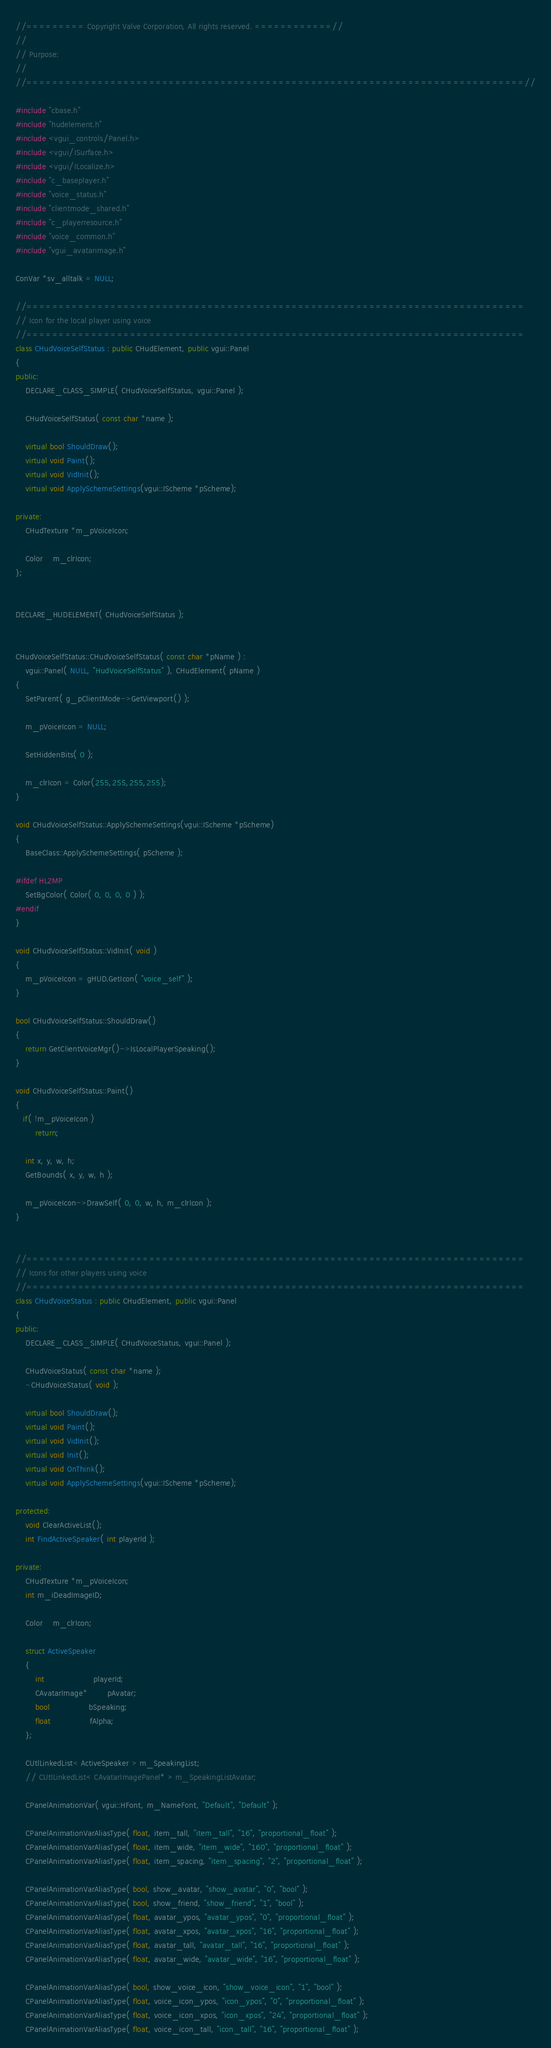Convert code to text. <code><loc_0><loc_0><loc_500><loc_500><_C++_>//========= Copyright Valve Corporation, All rights reserved. ============//
//
// Purpose: 
//
//=============================================================================//

#include "cbase.h"
#include "hudelement.h"
#include <vgui_controls/Panel.h>
#include <vgui/ISurface.h>
#include <vgui/ILocalize.h>
#include "c_baseplayer.h"
#include "voice_status.h"
#include "clientmode_shared.h"
#include "c_playerresource.h"
#include "voice_common.h"
#include "vgui_avatarimage.h"

ConVar *sv_alltalk = NULL;

//=============================================================================
// Icon for the local player using voice
//=============================================================================
class CHudVoiceSelfStatus : public CHudElement, public vgui::Panel
{
public:
	DECLARE_CLASS_SIMPLE( CHudVoiceSelfStatus, vgui::Panel );

	CHudVoiceSelfStatus( const char *name );

	virtual bool ShouldDraw();	
	virtual void Paint();
	virtual void VidInit();
	virtual void ApplySchemeSettings(vgui::IScheme *pScheme);

private:
	CHudTexture *m_pVoiceIcon;

	Color	m_clrIcon;
};


DECLARE_HUDELEMENT( CHudVoiceSelfStatus );


CHudVoiceSelfStatus::CHudVoiceSelfStatus( const char *pName ) :
	vgui::Panel( NULL, "HudVoiceSelfStatus" ), CHudElement( pName )
{
	SetParent( g_pClientMode->GetViewport() );

	m_pVoiceIcon = NULL;

	SetHiddenBits( 0 );

	m_clrIcon = Color(255,255,255,255);
}

void CHudVoiceSelfStatus::ApplySchemeSettings(vgui::IScheme *pScheme)
{
	BaseClass::ApplySchemeSettings( pScheme );

#ifdef HL2MP
	SetBgColor( Color( 0, 0, 0, 0 ) );
#endif
}

void CHudVoiceSelfStatus::VidInit( void )
{
	m_pVoiceIcon = gHUD.GetIcon( "voice_self" );
}

bool CHudVoiceSelfStatus::ShouldDraw()
{
	return GetClientVoiceMgr()->IsLocalPlayerSpeaking();
}

void CHudVoiceSelfStatus::Paint()
{
   if( !m_pVoiceIcon )
		return;
	
	int x, y, w, h;
	GetBounds( x, y, w, h );

	m_pVoiceIcon->DrawSelf( 0, 0, w, h, m_clrIcon );
}


//=============================================================================
// Icons for other players using voice
//=============================================================================
class CHudVoiceStatus : public CHudElement, public vgui::Panel
{
public:
	DECLARE_CLASS_SIMPLE( CHudVoiceStatus, vgui::Panel );

	CHudVoiceStatus( const char *name );
	~CHudVoiceStatus( void );

	virtual bool ShouldDraw();	
	virtual void Paint();
	virtual void VidInit();
	virtual void Init();
	virtual void OnThink();
	virtual void ApplySchemeSettings(vgui::IScheme *pScheme);

protected:
	void ClearActiveList();
	int FindActiveSpeaker( int playerId );

private:
	CHudTexture *m_pVoiceIcon;
	int m_iDeadImageID;

	Color	m_clrIcon;

	struct ActiveSpeaker
	{
		int					playerId;
		CAvatarImage*		pAvatar;
		bool				bSpeaking;
		float				fAlpha;
	};

	CUtlLinkedList< ActiveSpeaker > m_SpeakingList;
	// CUtlLinkedList< CAvatarImagePanel* > m_SpeakingListAvatar;

	CPanelAnimationVar( vgui::HFont, m_NameFont, "Default", "Default" );

	CPanelAnimationVarAliasType( float, item_tall, "item_tall", "16", "proportional_float" );
	CPanelAnimationVarAliasType( float, item_wide, "item_wide", "160", "proportional_float" );
	CPanelAnimationVarAliasType( float, item_spacing, "item_spacing", "2", "proportional_float" );

	CPanelAnimationVarAliasType( bool, show_avatar, "show_avatar", "0", "bool" );
	CPanelAnimationVarAliasType( bool, show_friend, "show_friend", "1", "bool" );
	CPanelAnimationVarAliasType( float, avatar_ypos, "avatar_ypos", "0", "proportional_float" );
	CPanelAnimationVarAliasType( float, avatar_xpos, "avatar_xpos", "16", "proportional_float" );
	CPanelAnimationVarAliasType( float, avatar_tall, "avatar_tall", "16", "proportional_float" );
	CPanelAnimationVarAliasType( float, avatar_wide, "avatar_wide", "16", "proportional_float" );

	CPanelAnimationVarAliasType( bool, show_voice_icon, "show_voice_icon", "1", "bool" );
	CPanelAnimationVarAliasType( float, voice_icon_ypos, "icon_ypos", "0", "proportional_float" );
	CPanelAnimationVarAliasType( float, voice_icon_xpos, "icon_xpos", "24", "proportional_float" );
	CPanelAnimationVarAliasType( float, voice_icon_tall, "icon_tall", "16", "proportional_float" );</code> 